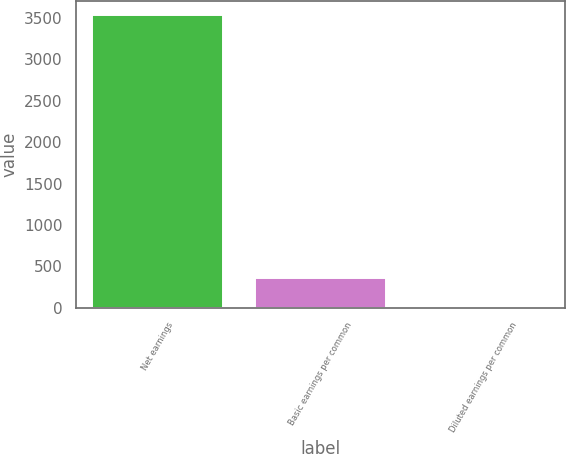Convert chart to OTSL. <chart><loc_0><loc_0><loc_500><loc_500><bar_chart><fcel>Net earnings<fcel>Basic earnings per common<fcel>Diluted earnings per common<nl><fcel>3534<fcel>363.51<fcel>11.23<nl></chart> 